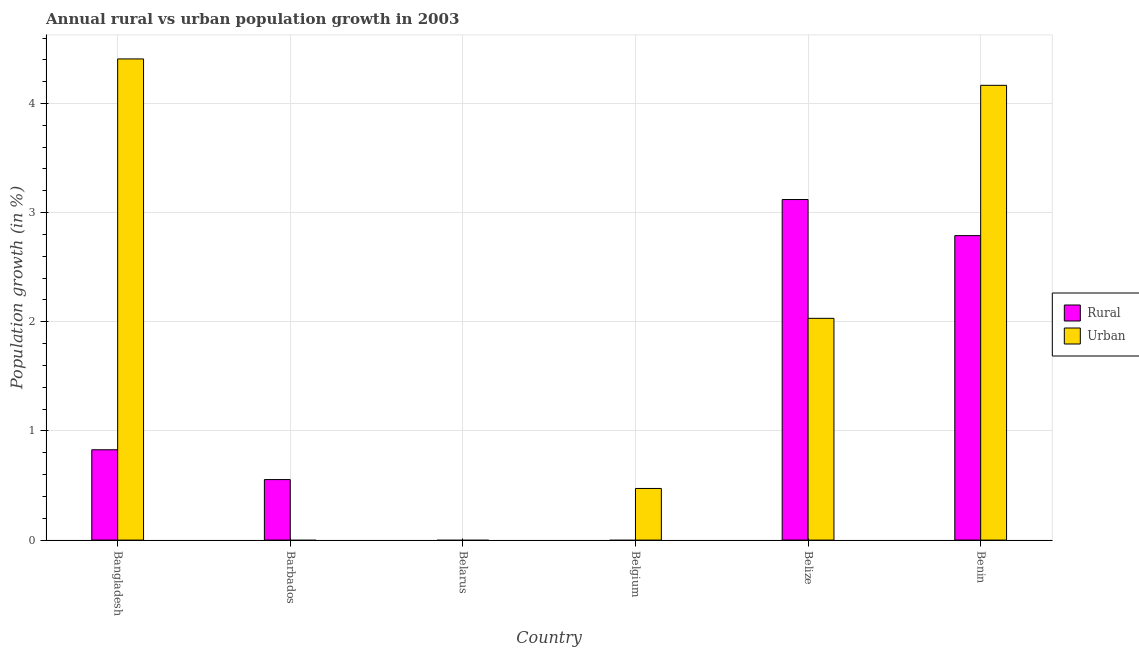Are the number of bars per tick equal to the number of legend labels?
Your answer should be very brief. No. Are the number of bars on each tick of the X-axis equal?
Offer a terse response. No. How many bars are there on the 3rd tick from the right?
Offer a terse response. 1. What is the label of the 5th group of bars from the left?
Your answer should be very brief. Belize. In how many cases, is the number of bars for a given country not equal to the number of legend labels?
Ensure brevity in your answer.  3. Across all countries, what is the maximum rural population growth?
Your answer should be very brief. 3.12. What is the total urban population growth in the graph?
Ensure brevity in your answer.  11.08. What is the difference between the urban population growth in Bangladesh and that in Benin?
Keep it short and to the point. 0.24. What is the difference between the rural population growth in Bangladesh and the urban population growth in Benin?
Give a very brief answer. -3.34. What is the average urban population growth per country?
Offer a terse response. 1.85. What is the difference between the urban population growth and rural population growth in Belize?
Your answer should be compact. -1.09. In how many countries, is the rural population growth greater than 1.6 %?
Offer a very short reply. 2. What is the ratio of the urban population growth in Belize to that in Benin?
Your answer should be compact. 0.49. What is the difference between the highest and the second highest rural population growth?
Ensure brevity in your answer.  0.33. What is the difference between the highest and the lowest urban population growth?
Provide a succinct answer. 4.41. In how many countries, is the rural population growth greater than the average rural population growth taken over all countries?
Give a very brief answer. 2. Does the graph contain any zero values?
Give a very brief answer. Yes. Where does the legend appear in the graph?
Make the answer very short. Center right. How many legend labels are there?
Keep it short and to the point. 2. What is the title of the graph?
Provide a succinct answer. Annual rural vs urban population growth in 2003. What is the label or title of the X-axis?
Provide a short and direct response. Country. What is the label or title of the Y-axis?
Your answer should be very brief. Population growth (in %). What is the Population growth (in %) of Rural in Bangladesh?
Give a very brief answer. 0.83. What is the Population growth (in %) of Urban  in Bangladesh?
Provide a succinct answer. 4.41. What is the Population growth (in %) in Rural in Barbados?
Offer a very short reply. 0.55. What is the Population growth (in %) of Urban  in Belgium?
Make the answer very short. 0.47. What is the Population growth (in %) of Rural in Belize?
Keep it short and to the point. 3.12. What is the Population growth (in %) in Urban  in Belize?
Your answer should be compact. 2.03. What is the Population growth (in %) of Rural in Benin?
Offer a very short reply. 2.79. What is the Population growth (in %) in Urban  in Benin?
Keep it short and to the point. 4.17. Across all countries, what is the maximum Population growth (in %) in Rural?
Ensure brevity in your answer.  3.12. Across all countries, what is the maximum Population growth (in %) of Urban ?
Offer a very short reply. 4.41. What is the total Population growth (in %) in Rural in the graph?
Provide a short and direct response. 7.29. What is the total Population growth (in %) of Urban  in the graph?
Ensure brevity in your answer.  11.08. What is the difference between the Population growth (in %) of Rural in Bangladesh and that in Barbados?
Provide a short and direct response. 0.27. What is the difference between the Population growth (in %) in Urban  in Bangladesh and that in Belgium?
Your response must be concise. 3.94. What is the difference between the Population growth (in %) of Rural in Bangladesh and that in Belize?
Keep it short and to the point. -2.29. What is the difference between the Population growth (in %) in Urban  in Bangladesh and that in Belize?
Keep it short and to the point. 2.38. What is the difference between the Population growth (in %) in Rural in Bangladesh and that in Benin?
Offer a terse response. -1.96. What is the difference between the Population growth (in %) in Urban  in Bangladesh and that in Benin?
Your answer should be very brief. 0.24. What is the difference between the Population growth (in %) in Rural in Barbados and that in Belize?
Keep it short and to the point. -2.57. What is the difference between the Population growth (in %) of Rural in Barbados and that in Benin?
Provide a short and direct response. -2.24. What is the difference between the Population growth (in %) in Urban  in Belgium and that in Belize?
Your answer should be very brief. -1.56. What is the difference between the Population growth (in %) of Urban  in Belgium and that in Benin?
Provide a short and direct response. -3.69. What is the difference between the Population growth (in %) of Rural in Belize and that in Benin?
Your answer should be very brief. 0.33. What is the difference between the Population growth (in %) in Urban  in Belize and that in Benin?
Ensure brevity in your answer.  -2.13. What is the difference between the Population growth (in %) in Rural in Bangladesh and the Population growth (in %) in Urban  in Belgium?
Your answer should be compact. 0.35. What is the difference between the Population growth (in %) in Rural in Bangladesh and the Population growth (in %) in Urban  in Belize?
Give a very brief answer. -1.2. What is the difference between the Population growth (in %) in Rural in Bangladesh and the Population growth (in %) in Urban  in Benin?
Ensure brevity in your answer.  -3.34. What is the difference between the Population growth (in %) in Rural in Barbados and the Population growth (in %) in Urban  in Belgium?
Offer a terse response. 0.08. What is the difference between the Population growth (in %) in Rural in Barbados and the Population growth (in %) in Urban  in Belize?
Your response must be concise. -1.48. What is the difference between the Population growth (in %) in Rural in Barbados and the Population growth (in %) in Urban  in Benin?
Your answer should be compact. -3.61. What is the difference between the Population growth (in %) in Rural in Belize and the Population growth (in %) in Urban  in Benin?
Offer a terse response. -1.05. What is the average Population growth (in %) in Rural per country?
Your answer should be very brief. 1.22. What is the average Population growth (in %) of Urban  per country?
Ensure brevity in your answer.  1.85. What is the difference between the Population growth (in %) of Rural and Population growth (in %) of Urban  in Bangladesh?
Ensure brevity in your answer.  -3.58. What is the difference between the Population growth (in %) in Rural and Population growth (in %) in Urban  in Belize?
Your answer should be very brief. 1.09. What is the difference between the Population growth (in %) in Rural and Population growth (in %) in Urban  in Benin?
Provide a succinct answer. -1.38. What is the ratio of the Population growth (in %) in Rural in Bangladesh to that in Barbados?
Provide a short and direct response. 1.49. What is the ratio of the Population growth (in %) of Urban  in Bangladesh to that in Belgium?
Your answer should be compact. 9.32. What is the ratio of the Population growth (in %) in Rural in Bangladesh to that in Belize?
Offer a terse response. 0.27. What is the ratio of the Population growth (in %) in Urban  in Bangladesh to that in Belize?
Your answer should be compact. 2.17. What is the ratio of the Population growth (in %) in Rural in Bangladesh to that in Benin?
Your answer should be compact. 0.3. What is the ratio of the Population growth (in %) of Urban  in Bangladesh to that in Benin?
Offer a terse response. 1.06. What is the ratio of the Population growth (in %) in Rural in Barbados to that in Belize?
Ensure brevity in your answer.  0.18. What is the ratio of the Population growth (in %) in Rural in Barbados to that in Benin?
Offer a terse response. 0.2. What is the ratio of the Population growth (in %) in Urban  in Belgium to that in Belize?
Make the answer very short. 0.23. What is the ratio of the Population growth (in %) of Urban  in Belgium to that in Benin?
Your answer should be very brief. 0.11. What is the ratio of the Population growth (in %) of Rural in Belize to that in Benin?
Ensure brevity in your answer.  1.12. What is the ratio of the Population growth (in %) in Urban  in Belize to that in Benin?
Make the answer very short. 0.49. What is the difference between the highest and the second highest Population growth (in %) in Rural?
Ensure brevity in your answer.  0.33. What is the difference between the highest and the second highest Population growth (in %) in Urban ?
Your answer should be compact. 0.24. What is the difference between the highest and the lowest Population growth (in %) in Rural?
Make the answer very short. 3.12. What is the difference between the highest and the lowest Population growth (in %) in Urban ?
Offer a terse response. 4.41. 